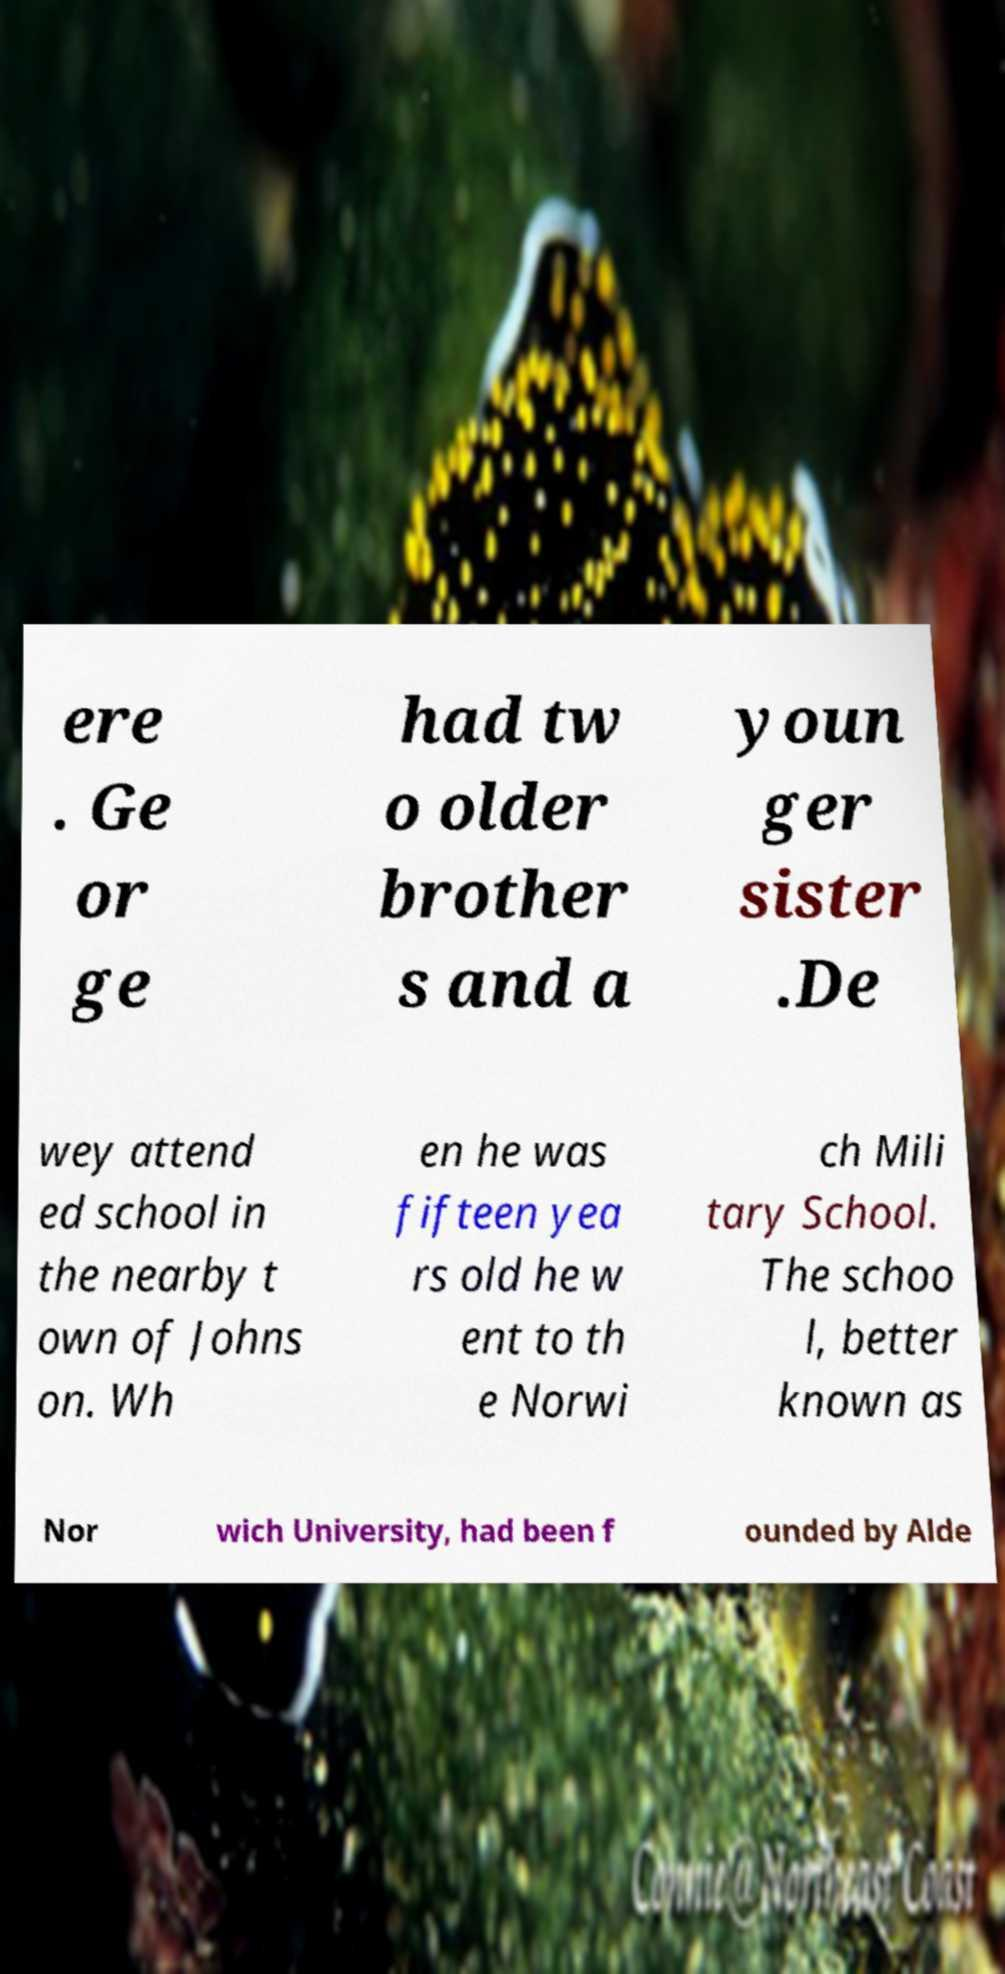There's text embedded in this image that I need extracted. Can you transcribe it verbatim? ere . Ge or ge had tw o older brother s and a youn ger sister .De wey attend ed school in the nearby t own of Johns on. Wh en he was fifteen yea rs old he w ent to th e Norwi ch Mili tary School. The schoo l, better known as Nor wich University, had been f ounded by Alde 